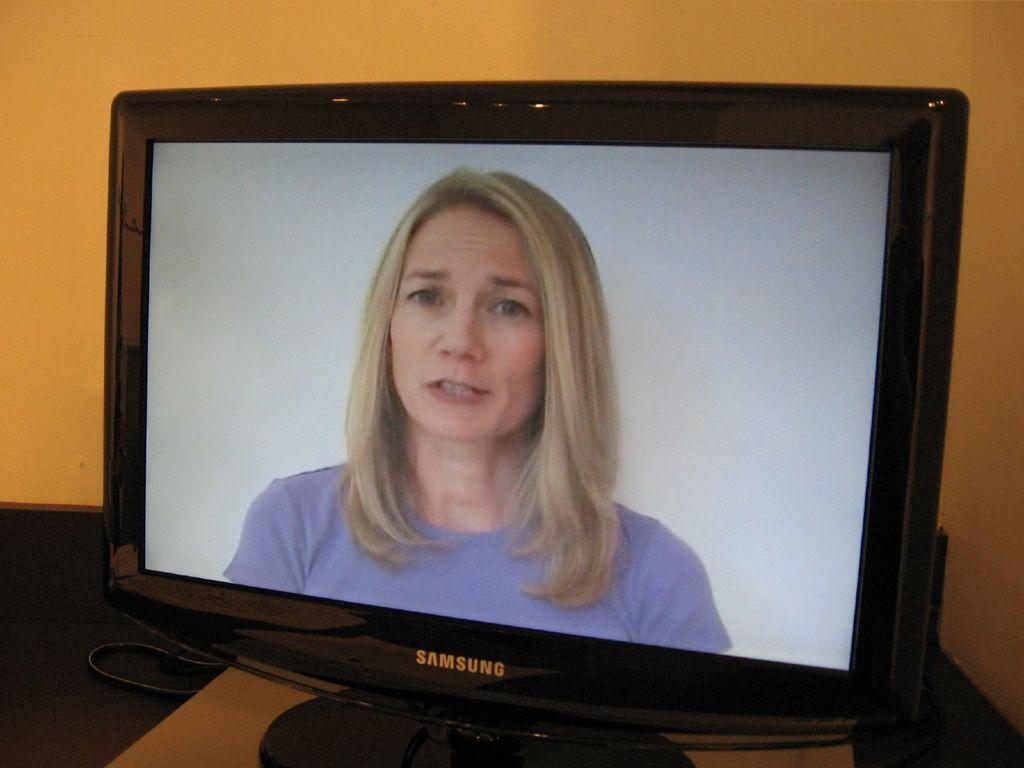Provide a one-sentence caption for the provided image. A woman in a purple shirt is on the the screen of the Samsung monitor. 